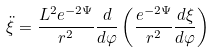<formula> <loc_0><loc_0><loc_500><loc_500>\ddot { \xi } = \frac { L ^ { 2 } e ^ { - 2 \Psi } } { r ^ { 2 } } \frac { d } { d \varphi } \left ( \frac { e ^ { - 2 \Psi } } { r ^ { 2 } } \frac { d \xi } { d \varphi } \right )</formula> 